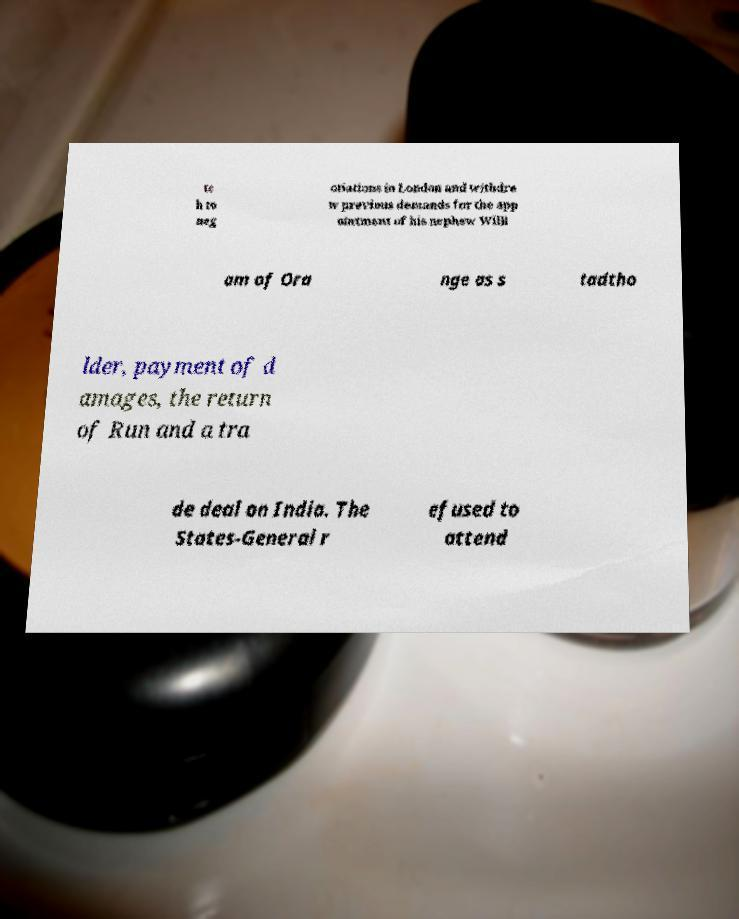Please identify and transcribe the text found in this image. tc h to neg otiations in London and withdre w previous demands for the app ointment of his nephew Willi am of Ora nge as s tadtho lder, payment of d amages, the return of Run and a tra de deal on India. The States-General r efused to attend 